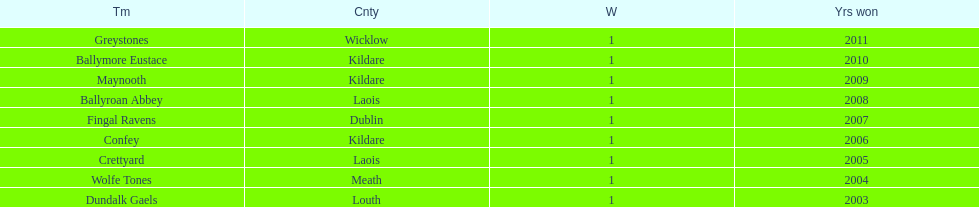What is the last team on the chart Dundalk Gaels. 